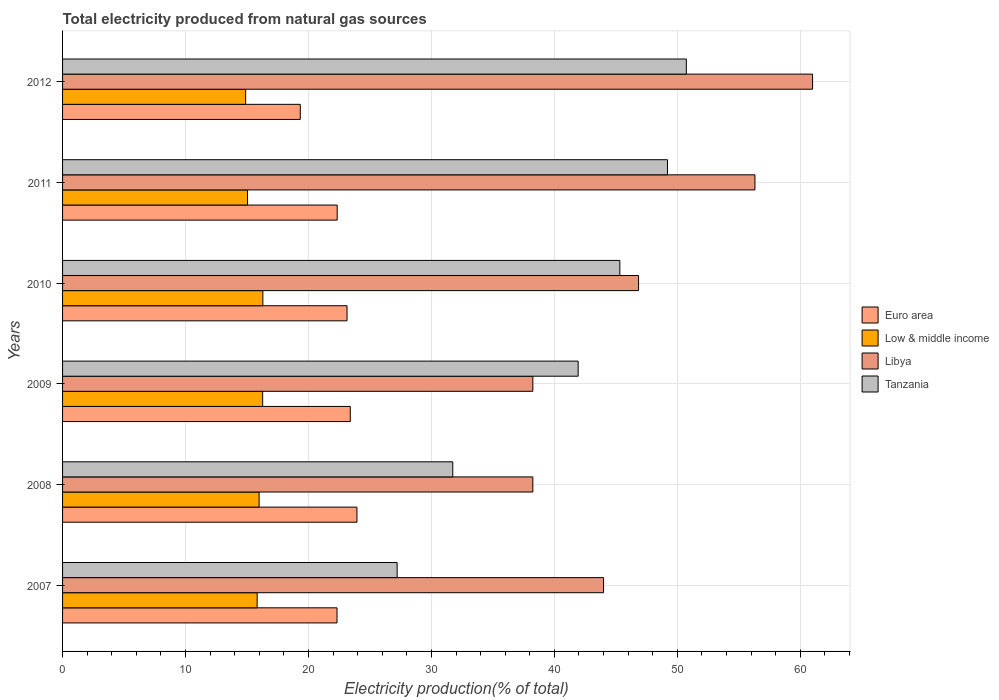How many groups of bars are there?
Provide a short and direct response. 6. How many bars are there on the 6th tick from the top?
Ensure brevity in your answer.  4. What is the label of the 4th group of bars from the top?
Offer a very short reply. 2009. In how many cases, is the number of bars for a given year not equal to the number of legend labels?
Ensure brevity in your answer.  0. What is the total electricity produced in Low & middle income in 2008?
Your answer should be compact. 15.99. Across all years, what is the maximum total electricity produced in Tanzania?
Offer a very short reply. 50.73. Across all years, what is the minimum total electricity produced in Low & middle income?
Give a very brief answer. 14.89. In which year was the total electricity produced in Tanzania minimum?
Provide a short and direct response. 2007. What is the total total electricity produced in Low & middle income in the graph?
Your answer should be compact. 94.31. What is the difference between the total electricity produced in Low & middle income in 2007 and that in 2010?
Your answer should be compact. -0.46. What is the difference between the total electricity produced in Libya in 2010 and the total electricity produced in Tanzania in 2011?
Keep it short and to the point. -2.35. What is the average total electricity produced in Low & middle income per year?
Provide a short and direct response. 15.72. In the year 2007, what is the difference between the total electricity produced in Euro area and total electricity produced in Low & middle income?
Make the answer very short. 6.5. In how many years, is the total electricity produced in Tanzania greater than 6 %?
Your answer should be compact. 6. What is the ratio of the total electricity produced in Libya in 2009 to that in 2012?
Provide a short and direct response. 0.63. Is the total electricity produced in Euro area in 2007 less than that in 2012?
Provide a short and direct response. No. Is the difference between the total electricity produced in Euro area in 2008 and 2010 greater than the difference between the total electricity produced in Low & middle income in 2008 and 2010?
Give a very brief answer. Yes. What is the difference between the highest and the second highest total electricity produced in Tanzania?
Give a very brief answer. 1.53. What is the difference between the highest and the lowest total electricity produced in Libya?
Give a very brief answer. 22.75. Is the sum of the total electricity produced in Tanzania in 2008 and 2009 greater than the maximum total electricity produced in Libya across all years?
Ensure brevity in your answer.  Yes. Is it the case that in every year, the sum of the total electricity produced in Low & middle income and total electricity produced in Libya is greater than the sum of total electricity produced in Euro area and total electricity produced in Tanzania?
Ensure brevity in your answer.  Yes. What does the 1st bar from the top in 2007 represents?
Your answer should be compact. Tanzania. What does the 1st bar from the bottom in 2009 represents?
Offer a terse response. Euro area. Is it the case that in every year, the sum of the total electricity produced in Tanzania and total electricity produced in Euro area is greater than the total electricity produced in Low & middle income?
Give a very brief answer. Yes. How many bars are there?
Your answer should be compact. 24. Are all the bars in the graph horizontal?
Keep it short and to the point. Yes. How many years are there in the graph?
Provide a short and direct response. 6. Does the graph contain any zero values?
Give a very brief answer. No. Does the graph contain grids?
Offer a very short reply. Yes. How many legend labels are there?
Give a very brief answer. 4. What is the title of the graph?
Offer a terse response. Total electricity produced from natural gas sources. Does "Fiji" appear as one of the legend labels in the graph?
Your response must be concise. No. What is the Electricity production(% of total) in Euro area in 2007?
Give a very brief answer. 22.32. What is the Electricity production(% of total) in Low & middle income in 2007?
Give a very brief answer. 15.83. What is the Electricity production(% of total) of Libya in 2007?
Your answer should be very brief. 44. What is the Electricity production(% of total) of Tanzania in 2007?
Offer a very short reply. 27.21. What is the Electricity production(% of total) in Euro area in 2008?
Offer a very short reply. 23.94. What is the Electricity production(% of total) of Low & middle income in 2008?
Make the answer very short. 15.99. What is the Electricity production(% of total) in Libya in 2008?
Provide a short and direct response. 38.25. What is the Electricity production(% of total) of Tanzania in 2008?
Provide a succinct answer. 31.74. What is the Electricity production(% of total) of Euro area in 2009?
Give a very brief answer. 23.4. What is the Electricity production(% of total) in Low & middle income in 2009?
Your answer should be compact. 16.27. What is the Electricity production(% of total) of Libya in 2009?
Provide a short and direct response. 38.25. What is the Electricity production(% of total) in Tanzania in 2009?
Keep it short and to the point. 41.93. What is the Electricity production(% of total) in Euro area in 2010?
Your answer should be compact. 23.14. What is the Electricity production(% of total) of Low & middle income in 2010?
Provide a succinct answer. 16.29. What is the Electricity production(% of total) in Libya in 2010?
Make the answer very short. 46.85. What is the Electricity production(% of total) in Tanzania in 2010?
Make the answer very short. 45.32. What is the Electricity production(% of total) in Euro area in 2011?
Ensure brevity in your answer.  22.34. What is the Electricity production(% of total) of Low & middle income in 2011?
Your response must be concise. 15.04. What is the Electricity production(% of total) of Libya in 2011?
Give a very brief answer. 56.31. What is the Electricity production(% of total) in Tanzania in 2011?
Your answer should be very brief. 49.2. What is the Electricity production(% of total) in Euro area in 2012?
Keep it short and to the point. 19.33. What is the Electricity production(% of total) of Low & middle income in 2012?
Provide a succinct answer. 14.89. What is the Electricity production(% of total) in Libya in 2012?
Your answer should be very brief. 61. What is the Electricity production(% of total) in Tanzania in 2012?
Offer a terse response. 50.73. Across all years, what is the maximum Electricity production(% of total) in Euro area?
Make the answer very short. 23.94. Across all years, what is the maximum Electricity production(% of total) in Low & middle income?
Your response must be concise. 16.29. Across all years, what is the maximum Electricity production(% of total) of Libya?
Give a very brief answer. 61. Across all years, what is the maximum Electricity production(% of total) in Tanzania?
Your answer should be very brief. 50.73. Across all years, what is the minimum Electricity production(% of total) of Euro area?
Offer a very short reply. 19.33. Across all years, what is the minimum Electricity production(% of total) of Low & middle income?
Offer a very short reply. 14.89. Across all years, what is the minimum Electricity production(% of total) of Libya?
Offer a very short reply. 38.25. Across all years, what is the minimum Electricity production(% of total) of Tanzania?
Provide a succinct answer. 27.21. What is the total Electricity production(% of total) in Euro area in the graph?
Give a very brief answer. 134.47. What is the total Electricity production(% of total) of Low & middle income in the graph?
Provide a succinct answer. 94.31. What is the total Electricity production(% of total) of Libya in the graph?
Your answer should be very brief. 284.66. What is the total Electricity production(% of total) of Tanzania in the graph?
Make the answer very short. 246.14. What is the difference between the Electricity production(% of total) in Euro area in 2007 and that in 2008?
Offer a terse response. -1.62. What is the difference between the Electricity production(% of total) in Low & middle income in 2007 and that in 2008?
Provide a short and direct response. -0.16. What is the difference between the Electricity production(% of total) in Libya in 2007 and that in 2008?
Your answer should be very brief. 5.75. What is the difference between the Electricity production(% of total) in Tanzania in 2007 and that in 2008?
Your response must be concise. -4.53. What is the difference between the Electricity production(% of total) of Euro area in 2007 and that in 2009?
Your answer should be very brief. -1.08. What is the difference between the Electricity production(% of total) in Low & middle income in 2007 and that in 2009?
Offer a terse response. -0.45. What is the difference between the Electricity production(% of total) in Libya in 2007 and that in 2009?
Provide a short and direct response. 5.75. What is the difference between the Electricity production(% of total) in Tanzania in 2007 and that in 2009?
Provide a short and direct response. -14.72. What is the difference between the Electricity production(% of total) of Euro area in 2007 and that in 2010?
Your response must be concise. -0.82. What is the difference between the Electricity production(% of total) in Low & middle income in 2007 and that in 2010?
Make the answer very short. -0.46. What is the difference between the Electricity production(% of total) in Libya in 2007 and that in 2010?
Your answer should be compact. -2.85. What is the difference between the Electricity production(% of total) in Tanzania in 2007 and that in 2010?
Provide a succinct answer. -18.11. What is the difference between the Electricity production(% of total) in Euro area in 2007 and that in 2011?
Give a very brief answer. -0.01. What is the difference between the Electricity production(% of total) in Low & middle income in 2007 and that in 2011?
Make the answer very short. 0.78. What is the difference between the Electricity production(% of total) of Libya in 2007 and that in 2011?
Provide a short and direct response. -12.31. What is the difference between the Electricity production(% of total) of Tanzania in 2007 and that in 2011?
Your response must be concise. -21.99. What is the difference between the Electricity production(% of total) of Euro area in 2007 and that in 2012?
Provide a succinct answer. 2.99. What is the difference between the Electricity production(% of total) of Low & middle income in 2007 and that in 2012?
Keep it short and to the point. 0.93. What is the difference between the Electricity production(% of total) of Libya in 2007 and that in 2012?
Offer a terse response. -17. What is the difference between the Electricity production(% of total) in Tanzania in 2007 and that in 2012?
Offer a terse response. -23.52. What is the difference between the Electricity production(% of total) of Euro area in 2008 and that in 2009?
Ensure brevity in your answer.  0.54. What is the difference between the Electricity production(% of total) in Low & middle income in 2008 and that in 2009?
Ensure brevity in your answer.  -0.29. What is the difference between the Electricity production(% of total) of Libya in 2008 and that in 2009?
Provide a succinct answer. -0. What is the difference between the Electricity production(% of total) in Tanzania in 2008 and that in 2009?
Offer a terse response. -10.2. What is the difference between the Electricity production(% of total) of Euro area in 2008 and that in 2010?
Keep it short and to the point. 0.81. What is the difference between the Electricity production(% of total) in Low & middle income in 2008 and that in 2010?
Provide a short and direct response. -0.3. What is the difference between the Electricity production(% of total) of Libya in 2008 and that in 2010?
Provide a short and direct response. -8.6. What is the difference between the Electricity production(% of total) in Tanzania in 2008 and that in 2010?
Offer a terse response. -13.59. What is the difference between the Electricity production(% of total) of Euro area in 2008 and that in 2011?
Provide a short and direct response. 1.61. What is the difference between the Electricity production(% of total) in Low & middle income in 2008 and that in 2011?
Give a very brief answer. 0.94. What is the difference between the Electricity production(% of total) of Libya in 2008 and that in 2011?
Your response must be concise. -18.06. What is the difference between the Electricity production(% of total) in Tanzania in 2008 and that in 2011?
Provide a succinct answer. -17.46. What is the difference between the Electricity production(% of total) of Euro area in 2008 and that in 2012?
Ensure brevity in your answer.  4.61. What is the difference between the Electricity production(% of total) of Low & middle income in 2008 and that in 2012?
Offer a terse response. 1.09. What is the difference between the Electricity production(% of total) in Libya in 2008 and that in 2012?
Make the answer very short. -22.75. What is the difference between the Electricity production(% of total) in Tanzania in 2008 and that in 2012?
Make the answer very short. -19. What is the difference between the Electricity production(% of total) of Euro area in 2009 and that in 2010?
Make the answer very short. 0.27. What is the difference between the Electricity production(% of total) of Low & middle income in 2009 and that in 2010?
Your answer should be very brief. -0.01. What is the difference between the Electricity production(% of total) of Libya in 2009 and that in 2010?
Provide a short and direct response. -8.6. What is the difference between the Electricity production(% of total) of Tanzania in 2009 and that in 2010?
Offer a terse response. -3.39. What is the difference between the Electricity production(% of total) of Euro area in 2009 and that in 2011?
Keep it short and to the point. 1.07. What is the difference between the Electricity production(% of total) of Low & middle income in 2009 and that in 2011?
Your response must be concise. 1.23. What is the difference between the Electricity production(% of total) of Libya in 2009 and that in 2011?
Make the answer very short. -18.06. What is the difference between the Electricity production(% of total) in Tanzania in 2009 and that in 2011?
Provide a short and direct response. -7.26. What is the difference between the Electricity production(% of total) of Euro area in 2009 and that in 2012?
Offer a terse response. 4.07. What is the difference between the Electricity production(% of total) in Low & middle income in 2009 and that in 2012?
Give a very brief answer. 1.38. What is the difference between the Electricity production(% of total) of Libya in 2009 and that in 2012?
Make the answer very short. -22.75. What is the difference between the Electricity production(% of total) in Tanzania in 2009 and that in 2012?
Give a very brief answer. -8.8. What is the difference between the Electricity production(% of total) in Euro area in 2010 and that in 2011?
Keep it short and to the point. 0.8. What is the difference between the Electricity production(% of total) of Low & middle income in 2010 and that in 2011?
Your response must be concise. 1.25. What is the difference between the Electricity production(% of total) of Libya in 2010 and that in 2011?
Keep it short and to the point. -9.46. What is the difference between the Electricity production(% of total) in Tanzania in 2010 and that in 2011?
Your response must be concise. -3.87. What is the difference between the Electricity production(% of total) in Euro area in 2010 and that in 2012?
Make the answer very short. 3.8. What is the difference between the Electricity production(% of total) of Low & middle income in 2010 and that in 2012?
Your response must be concise. 1.4. What is the difference between the Electricity production(% of total) of Libya in 2010 and that in 2012?
Provide a succinct answer. -14.15. What is the difference between the Electricity production(% of total) of Tanzania in 2010 and that in 2012?
Ensure brevity in your answer.  -5.41. What is the difference between the Electricity production(% of total) of Euro area in 2011 and that in 2012?
Offer a very short reply. 3. What is the difference between the Electricity production(% of total) of Low & middle income in 2011 and that in 2012?
Give a very brief answer. 0.15. What is the difference between the Electricity production(% of total) of Libya in 2011 and that in 2012?
Your response must be concise. -4.69. What is the difference between the Electricity production(% of total) of Tanzania in 2011 and that in 2012?
Your answer should be compact. -1.53. What is the difference between the Electricity production(% of total) in Euro area in 2007 and the Electricity production(% of total) in Low & middle income in 2008?
Keep it short and to the point. 6.34. What is the difference between the Electricity production(% of total) in Euro area in 2007 and the Electricity production(% of total) in Libya in 2008?
Make the answer very short. -15.93. What is the difference between the Electricity production(% of total) of Euro area in 2007 and the Electricity production(% of total) of Tanzania in 2008?
Ensure brevity in your answer.  -9.42. What is the difference between the Electricity production(% of total) of Low & middle income in 2007 and the Electricity production(% of total) of Libya in 2008?
Offer a terse response. -22.42. What is the difference between the Electricity production(% of total) of Low & middle income in 2007 and the Electricity production(% of total) of Tanzania in 2008?
Offer a very short reply. -15.91. What is the difference between the Electricity production(% of total) in Libya in 2007 and the Electricity production(% of total) in Tanzania in 2008?
Make the answer very short. 12.26. What is the difference between the Electricity production(% of total) of Euro area in 2007 and the Electricity production(% of total) of Low & middle income in 2009?
Make the answer very short. 6.05. What is the difference between the Electricity production(% of total) in Euro area in 2007 and the Electricity production(% of total) in Libya in 2009?
Keep it short and to the point. -15.93. What is the difference between the Electricity production(% of total) of Euro area in 2007 and the Electricity production(% of total) of Tanzania in 2009?
Keep it short and to the point. -19.61. What is the difference between the Electricity production(% of total) of Low & middle income in 2007 and the Electricity production(% of total) of Libya in 2009?
Make the answer very short. -22.42. What is the difference between the Electricity production(% of total) of Low & middle income in 2007 and the Electricity production(% of total) of Tanzania in 2009?
Provide a short and direct response. -26.11. What is the difference between the Electricity production(% of total) in Libya in 2007 and the Electricity production(% of total) in Tanzania in 2009?
Keep it short and to the point. 2.07. What is the difference between the Electricity production(% of total) in Euro area in 2007 and the Electricity production(% of total) in Low & middle income in 2010?
Your answer should be very brief. 6.03. What is the difference between the Electricity production(% of total) of Euro area in 2007 and the Electricity production(% of total) of Libya in 2010?
Offer a very short reply. -24.53. What is the difference between the Electricity production(% of total) in Euro area in 2007 and the Electricity production(% of total) in Tanzania in 2010?
Offer a very short reply. -23. What is the difference between the Electricity production(% of total) in Low & middle income in 2007 and the Electricity production(% of total) in Libya in 2010?
Give a very brief answer. -31.02. What is the difference between the Electricity production(% of total) in Low & middle income in 2007 and the Electricity production(% of total) in Tanzania in 2010?
Offer a terse response. -29.5. What is the difference between the Electricity production(% of total) in Libya in 2007 and the Electricity production(% of total) in Tanzania in 2010?
Provide a succinct answer. -1.32. What is the difference between the Electricity production(% of total) in Euro area in 2007 and the Electricity production(% of total) in Low & middle income in 2011?
Your answer should be compact. 7.28. What is the difference between the Electricity production(% of total) in Euro area in 2007 and the Electricity production(% of total) in Libya in 2011?
Make the answer very short. -33.99. What is the difference between the Electricity production(% of total) of Euro area in 2007 and the Electricity production(% of total) of Tanzania in 2011?
Offer a terse response. -26.88. What is the difference between the Electricity production(% of total) in Low & middle income in 2007 and the Electricity production(% of total) in Libya in 2011?
Keep it short and to the point. -40.49. What is the difference between the Electricity production(% of total) in Low & middle income in 2007 and the Electricity production(% of total) in Tanzania in 2011?
Offer a very short reply. -33.37. What is the difference between the Electricity production(% of total) in Libya in 2007 and the Electricity production(% of total) in Tanzania in 2011?
Your answer should be very brief. -5.2. What is the difference between the Electricity production(% of total) in Euro area in 2007 and the Electricity production(% of total) in Low & middle income in 2012?
Ensure brevity in your answer.  7.43. What is the difference between the Electricity production(% of total) in Euro area in 2007 and the Electricity production(% of total) in Libya in 2012?
Offer a very short reply. -38.68. What is the difference between the Electricity production(% of total) in Euro area in 2007 and the Electricity production(% of total) in Tanzania in 2012?
Keep it short and to the point. -28.41. What is the difference between the Electricity production(% of total) in Low & middle income in 2007 and the Electricity production(% of total) in Libya in 2012?
Offer a terse response. -45.17. What is the difference between the Electricity production(% of total) in Low & middle income in 2007 and the Electricity production(% of total) in Tanzania in 2012?
Make the answer very short. -34.91. What is the difference between the Electricity production(% of total) of Libya in 2007 and the Electricity production(% of total) of Tanzania in 2012?
Your response must be concise. -6.73. What is the difference between the Electricity production(% of total) in Euro area in 2008 and the Electricity production(% of total) in Low & middle income in 2009?
Give a very brief answer. 7.67. What is the difference between the Electricity production(% of total) in Euro area in 2008 and the Electricity production(% of total) in Libya in 2009?
Make the answer very short. -14.3. What is the difference between the Electricity production(% of total) in Euro area in 2008 and the Electricity production(% of total) in Tanzania in 2009?
Make the answer very short. -17.99. What is the difference between the Electricity production(% of total) of Low & middle income in 2008 and the Electricity production(% of total) of Libya in 2009?
Offer a very short reply. -22.26. What is the difference between the Electricity production(% of total) of Low & middle income in 2008 and the Electricity production(% of total) of Tanzania in 2009?
Make the answer very short. -25.95. What is the difference between the Electricity production(% of total) in Libya in 2008 and the Electricity production(% of total) in Tanzania in 2009?
Offer a terse response. -3.69. What is the difference between the Electricity production(% of total) in Euro area in 2008 and the Electricity production(% of total) in Low & middle income in 2010?
Offer a terse response. 7.65. What is the difference between the Electricity production(% of total) of Euro area in 2008 and the Electricity production(% of total) of Libya in 2010?
Give a very brief answer. -22.9. What is the difference between the Electricity production(% of total) in Euro area in 2008 and the Electricity production(% of total) in Tanzania in 2010?
Offer a terse response. -21.38. What is the difference between the Electricity production(% of total) in Low & middle income in 2008 and the Electricity production(% of total) in Libya in 2010?
Offer a terse response. -30.86. What is the difference between the Electricity production(% of total) in Low & middle income in 2008 and the Electricity production(% of total) in Tanzania in 2010?
Your answer should be very brief. -29.34. What is the difference between the Electricity production(% of total) in Libya in 2008 and the Electricity production(% of total) in Tanzania in 2010?
Your answer should be compact. -7.08. What is the difference between the Electricity production(% of total) in Euro area in 2008 and the Electricity production(% of total) in Low & middle income in 2011?
Keep it short and to the point. 8.9. What is the difference between the Electricity production(% of total) in Euro area in 2008 and the Electricity production(% of total) in Libya in 2011?
Your answer should be very brief. -32.37. What is the difference between the Electricity production(% of total) in Euro area in 2008 and the Electricity production(% of total) in Tanzania in 2011?
Provide a succinct answer. -25.26. What is the difference between the Electricity production(% of total) in Low & middle income in 2008 and the Electricity production(% of total) in Libya in 2011?
Ensure brevity in your answer.  -40.33. What is the difference between the Electricity production(% of total) in Low & middle income in 2008 and the Electricity production(% of total) in Tanzania in 2011?
Give a very brief answer. -33.21. What is the difference between the Electricity production(% of total) in Libya in 2008 and the Electricity production(% of total) in Tanzania in 2011?
Your response must be concise. -10.95. What is the difference between the Electricity production(% of total) of Euro area in 2008 and the Electricity production(% of total) of Low & middle income in 2012?
Keep it short and to the point. 9.05. What is the difference between the Electricity production(% of total) in Euro area in 2008 and the Electricity production(% of total) in Libya in 2012?
Make the answer very short. -37.06. What is the difference between the Electricity production(% of total) of Euro area in 2008 and the Electricity production(% of total) of Tanzania in 2012?
Provide a succinct answer. -26.79. What is the difference between the Electricity production(% of total) in Low & middle income in 2008 and the Electricity production(% of total) in Libya in 2012?
Your response must be concise. -45.02. What is the difference between the Electricity production(% of total) of Low & middle income in 2008 and the Electricity production(% of total) of Tanzania in 2012?
Your response must be concise. -34.75. What is the difference between the Electricity production(% of total) of Libya in 2008 and the Electricity production(% of total) of Tanzania in 2012?
Ensure brevity in your answer.  -12.49. What is the difference between the Electricity production(% of total) of Euro area in 2009 and the Electricity production(% of total) of Low & middle income in 2010?
Provide a succinct answer. 7.11. What is the difference between the Electricity production(% of total) in Euro area in 2009 and the Electricity production(% of total) in Libya in 2010?
Ensure brevity in your answer.  -23.45. What is the difference between the Electricity production(% of total) in Euro area in 2009 and the Electricity production(% of total) in Tanzania in 2010?
Keep it short and to the point. -21.92. What is the difference between the Electricity production(% of total) in Low & middle income in 2009 and the Electricity production(% of total) in Libya in 2010?
Your response must be concise. -30.57. What is the difference between the Electricity production(% of total) in Low & middle income in 2009 and the Electricity production(% of total) in Tanzania in 2010?
Offer a terse response. -29.05. What is the difference between the Electricity production(% of total) in Libya in 2009 and the Electricity production(% of total) in Tanzania in 2010?
Make the answer very short. -7.08. What is the difference between the Electricity production(% of total) in Euro area in 2009 and the Electricity production(% of total) in Low & middle income in 2011?
Your response must be concise. 8.36. What is the difference between the Electricity production(% of total) of Euro area in 2009 and the Electricity production(% of total) of Libya in 2011?
Offer a terse response. -32.91. What is the difference between the Electricity production(% of total) in Euro area in 2009 and the Electricity production(% of total) in Tanzania in 2011?
Provide a short and direct response. -25.8. What is the difference between the Electricity production(% of total) of Low & middle income in 2009 and the Electricity production(% of total) of Libya in 2011?
Provide a short and direct response. -40.04. What is the difference between the Electricity production(% of total) of Low & middle income in 2009 and the Electricity production(% of total) of Tanzania in 2011?
Your response must be concise. -32.92. What is the difference between the Electricity production(% of total) in Libya in 2009 and the Electricity production(% of total) in Tanzania in 2011?
Your answer should be compact. -10.95. What is the difference between the Electricity production(% of total) of Euro area in 2009 and the Electricity production(% of total) of Low & middle income in 2012?
Offer a very short reply. 8.51. What is the difference between the Electricity production(% of total) in Euro area in 2009 and the Electricity production(% of total) in Libya in 2012?
Offer a very short reply. -37.6. What is the difference between the Electricity production(% of total) in Euro area in 2009 and the Electricity production(% of total) in Tanzania in 2012?
Keep it short and to the point. -27.33. What is the difference between the Electricity production(% of total) in Low & middle income in 2009 and the Electricity production(% of total) in Libya in 2012?
Provide a succinct answer. -44.73. What is the difference between the Electricity production(% of total) of Low & middle income in 2009 and the Electricity production(% of total) of Tanzania in 2012?
Your answer should be compact. -34.46. What is the difference between the Electricity production(% of total) in Libya in 2009 and the Electricity production(% of total) in Tanzania in 2012?
Your answer should be compact. -12.49. What is the difference between the Electricity production(% of total) of Euro area in 2010 and the Electricity production(% of total) of Low & middle income in 2011?
Provide a short and direct response. 8.09. What is the difference between the Electricity production(% of total) of Euro area in 2010 and the Electricity production(% of total) of Libya in 2011?
Keep it short and to the point. -33.18. What is the difference between the Electricity production(% of total) in Euro area in 2010 and the Electricity production(% of total) in Tanzania in 2011?
Your response must be concise. -26.06. What is the difference between the Electricity production(% of total) of Low & middle income in 2010 and the Electricity production(% of total) of Libya in 2011?
Provide a succinct answer. -40.02. What is the difference between the Electricity production(% of total) in Low & middle income in 2010 and the Electricity production(% of total) in Tanzania in 2011?
Provide a short and direct response. -32.91. What is the difference between the Electricity production(% of total) of Libya in 2010 and the Electricity production(% of total) of Tanzania in 2011?
Provide a succinct answer. -2.35. What is the difference between the Electricity production(% of total) of Euro area in 2010 and the Electricity production(% of total) of Low & middle income in 2012?
Your answer should be very brief. 8.24. What is the difference between the Electricity production(% of total) of Euro area in 2010 and the Electricity production(% of total) of Libya in 2012?
Your response must be concise. -37.86. What is the difference between the Electricity production(% of total) in Euro area in 2010 and the Electricity production(% of total) in Tanzania in 2012?
Give a very brief answer. -27.6. What is the difference between the Electricity production(% of total) of Low & middle income in 2010 and the Electricity production(% of total) of Libya in 2012?
Ensure brevity in your answer.  -44.71. What is the difference between the Electricity production(% of total) in Low & middle income in 2010 and the Electricity production(% of total) in Tanzania in 2012?
Provide a short and direct response. -34.44. What is the difference between the Electricity production(% of total) in Libya in 2010 and the Electricity production(% of total) in Tanzania in 2012?
Offer a terse response. -3.89. What is the difference between the Electricity production(% of total) in Euro area in 2011 and the Electricity production(% of total) in Low & middle income in 2012?
Your response must be concise. 7.44. What is the difference between the Electricity production(% of total) in Euro area in 2011 and the Electricity production(% of total) in Libya in 2012?
Your response must be concise. -38.67. What is the difference between the Electricity production(% of total) in Euro area in 2011 and the Electricity production(% of total) in Tanzania in 2012?
Your answer should be compact. -28.4. What is the difference between the Electricity production(% of total) in Low & middle income in 2011 and the Electricity production(% of total) in Libya in 2012?
Your answer should be compact. -45.96. What is the difference between the Electricity production(% of total) in Low & middle income in 2011 and the Electricity production(% of total) in Tanzania in 2012?
Ensure brevity in your answer.  -35.69. What is the difference between the Electricity production(% of total) of Libya in 2011 and the Electricity production(% of total) of Tanzania in 2012?
Keep it short and to the point. 5.58. What is the average Electricity production(% of total) in Euro area per year?
Offer a terse response. 22.41. What is the average Electricity production(% of total) of Low & middle income per year?
Provide a succinct answer. 15.72. What is the average Electricity production(% of total) of Libya per year?
Ensure brevity in your answer.  47.44. What is the average Electricity production(% of total) in Tanzania per year?
Provide a short and direct response. 41.02. In the year 2007, what is the difference between the Electricity production(% of total) in Euro area and Electricity production(% of total) in Low & middle income?
Offer a terse response. 6.5. In the year 2007, what is the difference between the Electricity production(% of total) of Euro area and Electricity production(% of total) of Libya?
Ensure brevity in your answer.  -21.68. In the year 2007, what is the difference between the Electricity production(% of total) of Euro area and Electricity production(% of total) of Tanzania?
Your answer should be compact. -4.89. In the year 2007, what is the difference between the Electricity production(% of total) of Low & middle income and Electricity production(% of total) of Libya?
Your response must be concise. -28.17. In the year 2007, what is the difference between the Electricity production(% of total) in Low & middle income and Electricity production(% of total) in Tanzania?
Provide a succinct answer. -11.39. In the year 2007, what is the difference between the Electricity production(% of total) in Libya and Electricity production(% of total) in Tanzania?
Make the answer very short. 16.79. In the year 2008, what is the difference between the Electricity production(% of total) in Euro area and Electricity production(% of total) in Low & middle income?
Keep it short and to the point. 7.96. In the year 2008, what is the difference between the Electricity production(% of total) of Euro area and Electricity production(% of total) of Libya?
Ensure brevity in your answer.  -14.3. In the year 2008, what is the difference between the Electricity production(% of total) in Euro area and Electricity production(% of total) in Tanzania?
Offer a terse response. -7.79. In the year 2008, what is the difference between the Electricity production(% of total) of Low & middle income and Electricity production(% of total) of Libya?
Offer a very short reply. -22.26. In the year 2008, what is the difference between the Electricity production(% of total) of Low & middle income and Electricity production(% of total) of Tanzania?
Give a very brief answer. -15.75. In the year 2008, what is the difference between the Electricity production(% of total) in Libya and Electricity production(% of total) in Tanzania?
Offer a terse response. 6.51. In the year 2009, what is the difference between the Electricity production(% of total) of Euro area and Electricity production(% of total) of Low & middle income?
Give a very brief answer. 7.13. In the year 2009, what is the difference between the Electricity production(% of total) of Euro area and Electricity production(% of total) of Libya?
Give a very brief answer. -14.85. In the year 2009, what is the difference between the Electricity production(% of total) of Euro area and Electricity production(% of total) of Tanzania?
Your answer should be very brief. -18.53. In the year 2009, what is the difference between the Electricity production(% of total) of Low & middle income and Electricity production(% of total) of Libya?
Provide a succinct answer. -21.97. In the year 2009, what is the difference between the Electricity production(% of total) of Low & middle income and Electricity production(% of total) of Tanzania?
Give a very brief answer. -25.66. In the year 2009, what is the difference between the Electricity production(% of total) in Libya and Electricity production(% of total) in Tanzania?
Keep it short and to the point. -3.69. In the year 2010, what is the difference between the Electricity production(% of total) of Euro area and Electricity production(% of total) of Low & middle income?
Make the answer very short. 6.85. In the year 2010, what is the difference between the Electricity production(% of total) of Euro area and Electricity production(% of total) of Libya?
Ensure brevity in your answer.  -23.71. In the year 2010, what is the difference between the Electricity production(% of total) of Euro area and Electricity production(% of total) of Tanzania?
Offer a terse response. -22.19. In the year 2010, what is the difference between the Electricity production(% of total) in Low & middle income and Electricity production(% of total) in Libya?
Offer a terse response. -30.56. In the year 2010, what is the difference between the Electricity production(% of total) in Low & middle income and Electricity production(% of total) in Tanzania?
Provide a succinct answer. -29.04. In the year 2010, what is the difference between the Electricity production(% of total) of Libya and Electricity production(% of total) of Tanzania?
Offer a terse response. 1.52. In the year 2011, what is the difference between the Electricity production(% of total) of Euro area and Electricity production(% of total) of Low & middle income?
Make the answer very short. 7.29. In the year 2011, what is the difference between the Electricity production(% of total) of Euro area and Electricity production(% of total) of Libya?
Your answer should be very brief. -33.98. In the year 2011, what is the difference between the Electricity production(% of total) of Euro area and Electricity production(% of total) of Tanzania?
Provide a succinct answer. -26.86. In the year 2011, what is the difference between the Electricity production(% of total) of Low & middle income and Electricity production(% of total) of Libya?
Make the answer very short. -41.27. In the year 2011, what is the difference between the Electricity production(% of total) of Low & middle income and Electricity production(% of total) of Tanzania?
Your answer should be compact. -34.16. In the year 2011, what is the difference between the Electricity production(% of total) of Libya and Electricity production(% of total) of Tanzania?
Your answer should be compact. 7.11. In the year 2012, what is the difference between the Electricity production(% of total) in Euro area and Electricity production(% of total) in Low & middle income?
Offer a terse response. 4.44. In the year 2012, what is the difference between the Electricity production(% of total) in Euro area and Electricity production(% of total) in Libya?
Offer a very short reply. -41.67. In the year 2012, what is the difference between the Electricity production(% of total) in Euro area and Electricity production(% of total) in Tanzania?
Provide a succinct answer. -31.4. In the year 2012, what is the difference between the Electricity production(% of total) in Low & middle income and Electricity production(% of total) in Libya?
Your answer should be compact. -46.11. In the year 2012, what is the difference between the Electricity production(% of total) in Low & middle income and Electricity production(% of total) in Tanzania?
Make the answer very short. -35.84. In the year 2012, what is the difference between the Electricity production(% of total) of Libya and Electricity production(% of total) of Tanzania?
Offer a terse response. 10.27. What is the ratio of the Electricity production(% of total) of Euro area in 2007 to that in 2008?
Provide a short and direct response. 0.93. What is the ratio of the Electricity production(% of total) in Libya in 2007 to that in 2008?
Give a very brief answer. 1.15. What is the ratio of the Electricity production(% of total) of Tanzania in 2007 to that in 2008?
Ensure brevity in your answer.  0.86. What is the ratio of the Electricity production(% of total) in Euro area in 2007 to that in 2009?
Your response must be concise. 0.95. What is the ratio of the Electricity production(% of total) in Low & middle income in 2007 to that in 2009?
Offer a very short reply. 0.97. What is the ratio of the Electricity production(% of total) in Libya in 2007 to that in 2009?
Keep it short and to the point. 1.15. What is the ratio of the Electricity production(% of total) of Tanzania in 2007 to that in 2009?
Your answer should be very brief. 0.65. What is the ratio of the Electricity production(% of total) in Euro area in 2007 to that in 2010?
Give a very brief answer. 0.96. What is the ratio of the Electricity production(% of total) in Low & middle income in 2007 to that in 2010?
Provide a succinct answer. 0.97. What is the ratio of the Electricity production(% of total) in Libya in 2007 to that in 2010?
Offer a terse response. 0.94. What is the ratio of the Electricity production(% of total) in Tanzania in 2007 to that in 2010?
Your answer should be compact. 0.6. What is the ratio of the Electricity production(% of total) of Low & middle income in 2007 to that in 2011?
Provide a short and direct response. 1.05. What is the ratio of the Electricity production(% of total) of Libya in 2007 to that in 2011?
Provide a short and direct response. 0.78. What is the ratio of the Electricity production(% of total) in Tanzania in 2007 to that in 2011?
Ensure brevity in your answer.  0.55. What is the ratio of the Electricity production(% of total) of Euro area in 2007 to that in 2012?
Your response must be concise. 1.15. What is the ratio of the Electricity production(% of total) of Low & middle income in 2007 to that in 2012?
Provide a succinct answer. 1.06. What is the ratio of the Electricity production(% of total) in Libya in 2007 to that in 2012?
Give a very brief answer. 0.72. What is the ratio of the Electricity production(% of total) of Tanzania in 2007 to that in 2012?
Keep it short and to the point. 0.54. What is the ratio of the Electricity production(% of total) of Euro area in 2008 to that in 2009?
Keep it short and to the point. 1.02. What is the ratio of the Electricity production(% of total) of Low & middle income in 2008 to that in 2009?
Ensure brevity in your answer.  0.98. What is the ratio of the Electricity production(% of total) in Tanzania in 2008 to that in 2009?
Keep it short and to the point. 0.76. What is the ratio of the Electricity production(% of total) of Euro area in 2008 to that in 2010?
Give a very brief answer. 1.03. What is the ratio of the Electricity production(% of total) of Low & middle income in 2008 to that in 2010?
Provide a succinct answer. 0.98. What is the ratio of the Electricity production(% of total) in Libya in 2008 to that in 2010?
Make the answer very short. 0.82. What is the ratio of the Electricity production(% of total) in Tanzania in 2008 to that in 2010?
Provide a short and direct response. 0.7. What is the ratio of the Electricity production(% of total) of Euro area in 2008 to that in 2011?
Provide a short and direct response. 1.07. What is the ratio of the Electricity production(% of total) of Low & middle income in 2008 to that in 2011?
Provide a succinct answer. 1.06. What is the ratio of the Electricity production(% of total) in Libya in 2008 to that in 2011?
Your answer should be very brief. 0.68. What is the ratio of the Electricity production(% of total) in Tanzania in 2008 to that in 2011?
Offer a very short reply. 0.65. What is the ratio of the Electricity production(% of total) in Euro area in 2008 to that in 2012?
Offer a very short reply. 1.24. What is the ratio of the Electricity production(% of total) of Low & middle income in 2008 to that in 2012?
Make the answer very short. 1.07. What is the ratio of the Electricity production(% of total) in Libya in 2008 to that in 2012?
Your answer should be very brief. 0.63. What is the ratio of the Electricity production(% of total) in Tanzania in 2008 to that in 2012?
Your answer should be compact. 0.63. What is the ratio of the Electricity production(% of total) of Euro area in 2009 to that in 2010?
Your answer should be very brief. 1.01. What is the ratio of the Electricity production(% of total) in Libya in 2009 to that in 2010?
Ensure brevity in your answer.  0.82. What is the ratio of the Electricity production(% of total) in Tanzania in 2009 to that in 2010?
Provide a succinct answer. 0.93. What is the ratio of the Electricity production(% of total) of Euro area in 2009 to that in 2011?
Provide a succinct answer. 1.05. What is the ratio of the Electricity production(% of total) in Low & middle income in 2009 to that in 2011?
Your answer should be compact. 1.08. What is the ratio of the Electricity production(% of total) in Libya in 2009 to that in 2011?
Keep it short and to the point. 0.68. What is the ratio of the Electricity production(% of total) of Tanzania in 2009 to that in 2011?
Your answer should be very brief. 0.85. What is the ratio of the Electricity production(% of total) in Euro area in 2009 to that in 2012?
Keep it short and to the point. 1.21. What is the ratio of the Electricity production(% of total) of Low & middle income in 2009 to that in 2012?
Your answer should be very brief. 1.09. What is the ratio of the Electricity production(% of total) in Libya in 2009 to that in 2012?
Offer a very short reply. 0.63. What is the ratio of the Electricity production(% of total) in Tanzania in 2009 to that in 2012?
Provide a succinct answer. 0.83. What is the ratio of the Electricity production(% of total) of Euro area in 2010 to that in 2011?
Offer a very short reply. 1.04. What is the ratio of the Electricity production(% of total) in Low & middle income in 2010 to that in 2011?
Make the answer very short. 1.08. What is the ratio of the Electricity production(% of total) in Libya in 2010 to that in 2011?
Give a very brief answer. 0.83. What is the ratio of the Electricity production(% of total) in Tanzania in 2010 to that in 2011?
Provide a short and direct response. 0.92. What is the ratio of the Electricity production(% of total) in Euro area in 2010 to that in 2012?
Ensure brevity in your answer.  1.2. What is the ratio of the Electricity production(% of total) in Low & middle income in 2010 to that in 2012?
Offer a terse response. 1.09. What is the ratio of the Electricity production(% of total) in Libya in 2010 to that in 2012?
Your response must be concise. 0.77. What is the ratio of the Electricity production(% of total) of Tanzania in 2010 to that in 2012?
Your answer should be compact. 0.89. What is the ratio of the Electricity production(% of total) in Euro area in 2011 to that in 2012?
Provide a short and direct response. 1.16. What is the ratio of the Electricity production(% of total) in Low & middle income in 2011 to that in 2012?
Your answer should be very brief. 1.01. What is the ratio of the Electricity production(% of total) of Tanzania in 2011 to that in 2012?
Ensure brevity in your answer.  0.97. What is the difference between the highest and the second highest Electricity production(% of total) of Euro area?
Your response must be concise. 0.54. What is the difference between the highest and the second highest Electricity production(% of total) of Low & middle income?
Provide a succinct answer. 0.01. What is the difference between the highest and the second highest Electricity production(% of total) in Libya?
Provide a succinct answer. 4.69. What is the difference between the highest and the second highest Electricity production(% of total) in Tanzania?
Provide a short and direct response. 1.53. What is the difference between the highest and the lowest Electricity production(% of total) of Euro area?
Provide a succinct answer. 4.61. What is the difference between the highest and the lowest Electricity production(% of total) of Low & middle income?
Offer a very short reply. 1.4. What is the difference between the highest and the lowest Electricity production(% of total) in Libya?
Offer a terse response. 22.75. What is the difference between the highest and the lowest Electricity production(% of total) of Tanzania?
Make the answer very short. 23.52. 